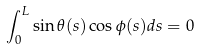<formula> <loc_0><loc_0><loc_500><loc_500>\int _ { 0 } ^ { L } \sin \theta ( s ) \cos \phi ( s ) d s = 0</formula> 